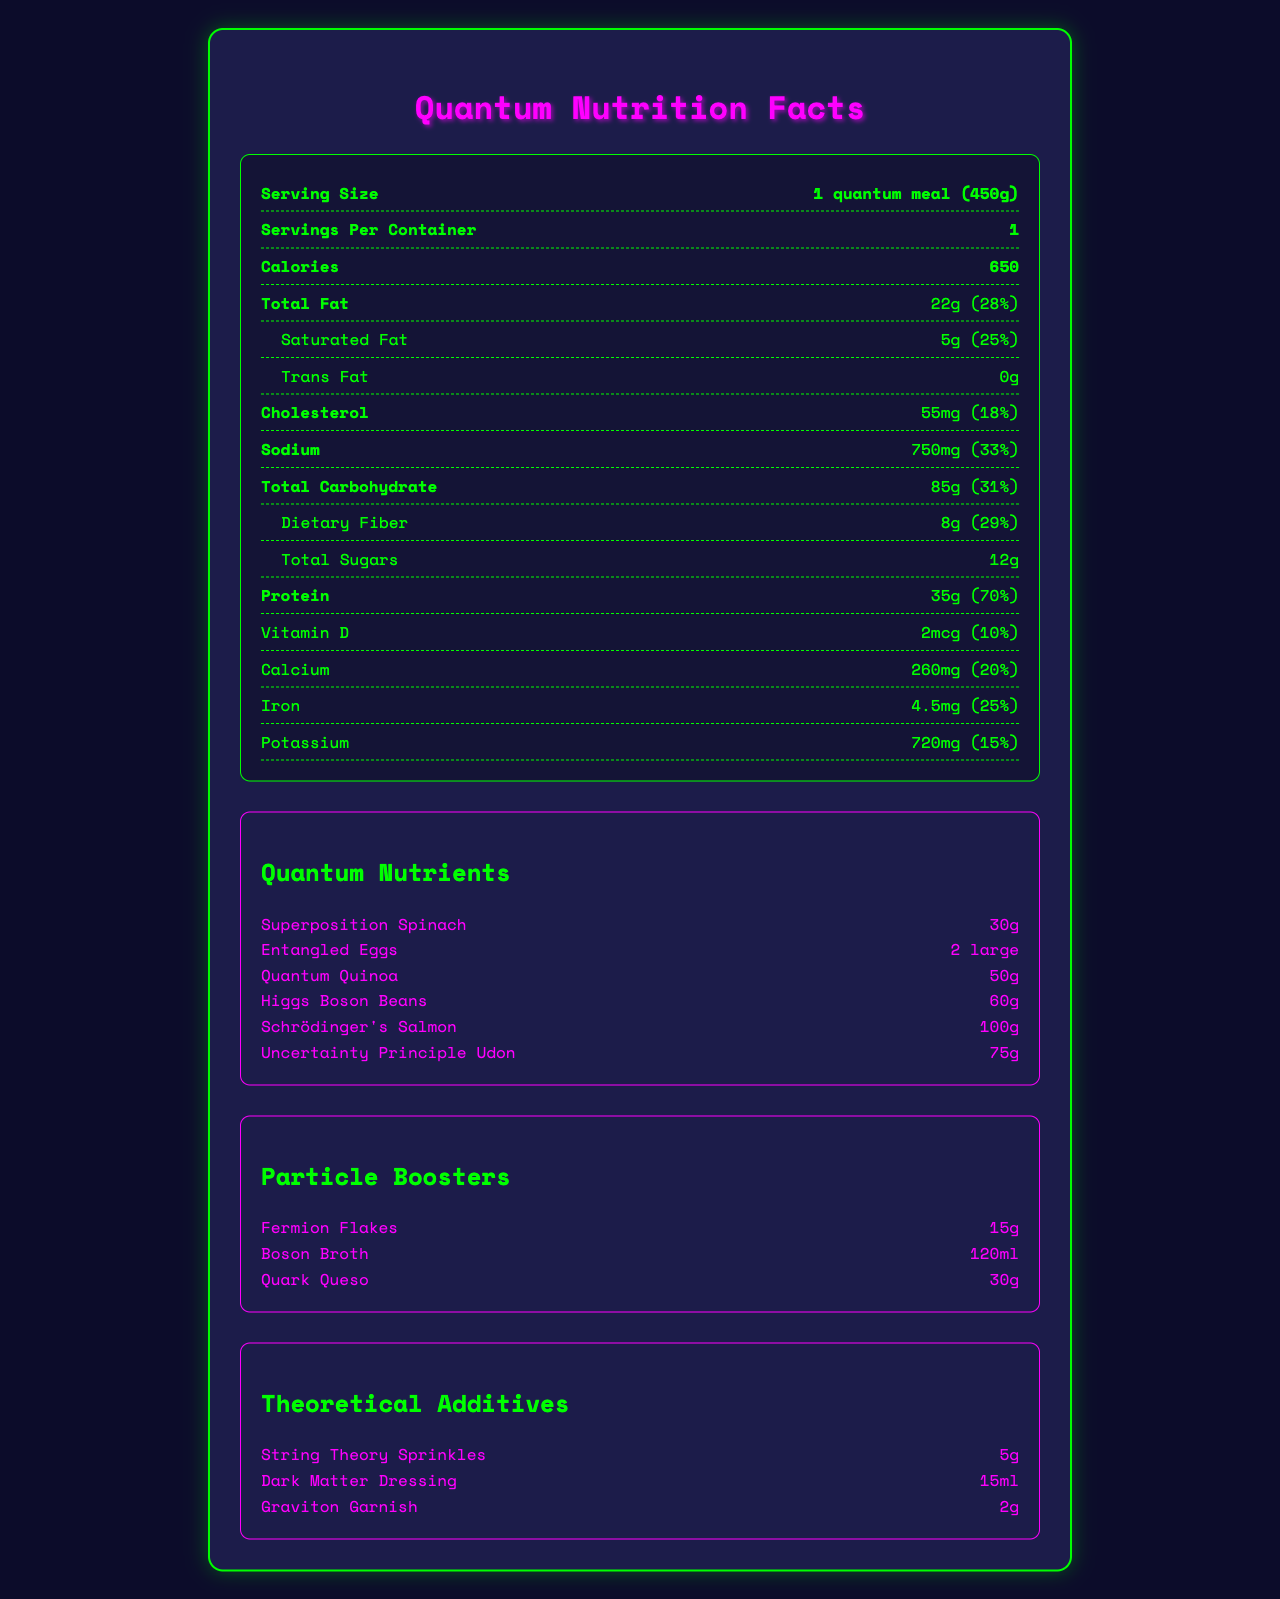what is the serving size? This information is at the top of the Nutrition Facts section under "Serving Size."
Answer: 1 quantum meal (450g) how many calories are in one quantum meal? This information is provided in the bold "Calories" row in the Nutrition Facts section.
Answer: 650 calories what is the percentage of Daily Value for sodium? This information is listed next to the sodium amount in the Nutrition Facts section.
Answer: 33% list the components of total fat? These components are listed under the "Total Fat" section with their respective amounts and percentages where applicable.
Answer: Saturated Fat (5g, 25%), Trans Fat (0g), Polyunsaturated Fat (4g), Monounsaturated Fat (13g) how much protein does one quantum meal contain? This information is listed in the row for "Protein" in the Nutrition Facts section.
Answer: 35g (70%) which type of fat has the highest percentage of daily value? A. Saturated Fat B. Trans Fat C. Polyunsaturated Fat D. Monounsaturated Fat Saturated Fat has a Daily Value percentage of 25%, which is comparative to other types of fat like Trans Fat, which is 0%, and other unspecified fats.
Answer: A. Saturated Fat how many servings per container? A. 1 B. 2 C. 4 D. 6 The document lists "Servings Per Container" as 1, making option A the correct answer.
Answer: A. 1 does the quantum meal contain added sugars? The document specifies "Includes 5g Added Sugars" in the "Total Carbohydrate" section.
Answer: Yes describe the main idea of the document. This Nutritional Facts label offers a comprehensive overview of conventional and imaginative nutritional components in a standardized quantum-themed meal.
Answer: The document provides detailed nutritional information for a "Quantum Meal", highlighting traditional nutrients such as fats, carbohydrates, protein, vitamins, and minerals, alongside uniquely themed quantum nutrients, particle boosters, and theoretical additives. what is the amount of calcium present in one serving? This information can be found under the "Calcium" row in the Nutrition Facts section.
Answer: 260mg (20%) how much Polyunsaturated Fat is in the quantum meal? This is listed under the "Total Fat" section as one of its components.
Answer: 4g which quantum nutrient is listed in the highest amount? A. Superposition Spinach B. Entangled Eggs C. Schrödinger's Salmon D. Uncertainty Principle Udon Schrödinger's Salmon is listed with 100g, the highest amount among the options, in the quantum nutrient section.
Answer: C. Schrödinger's Salmon is the exact ratio of different carbs (simple vs complex) available? The document does not provide enough detail to differentiate between the amounts of various types of carbohydrates (simple vs complex) beyond listing sugars and dietary fibers.
Answer: Not enough information what is the total amount of fiber in the quantum meal? This information is listed under the "Dietary Fiber" component of the "Total Carbohydrate" section.
Answer: 8g (29%) explain the significance of the "theoretical additives" in the quantum meal description. These unique items enhance the theme and engage those with an interest in theoretical physics while being part of a playful nod to the scientific community.
Answer: The theoretical additives (String Theory Sprinkles, Dark Matter Dressing, Graviton Garnish) are part of the document's creative flair, merging elements of advanced physics concepts into the meal's nutritional profile. 